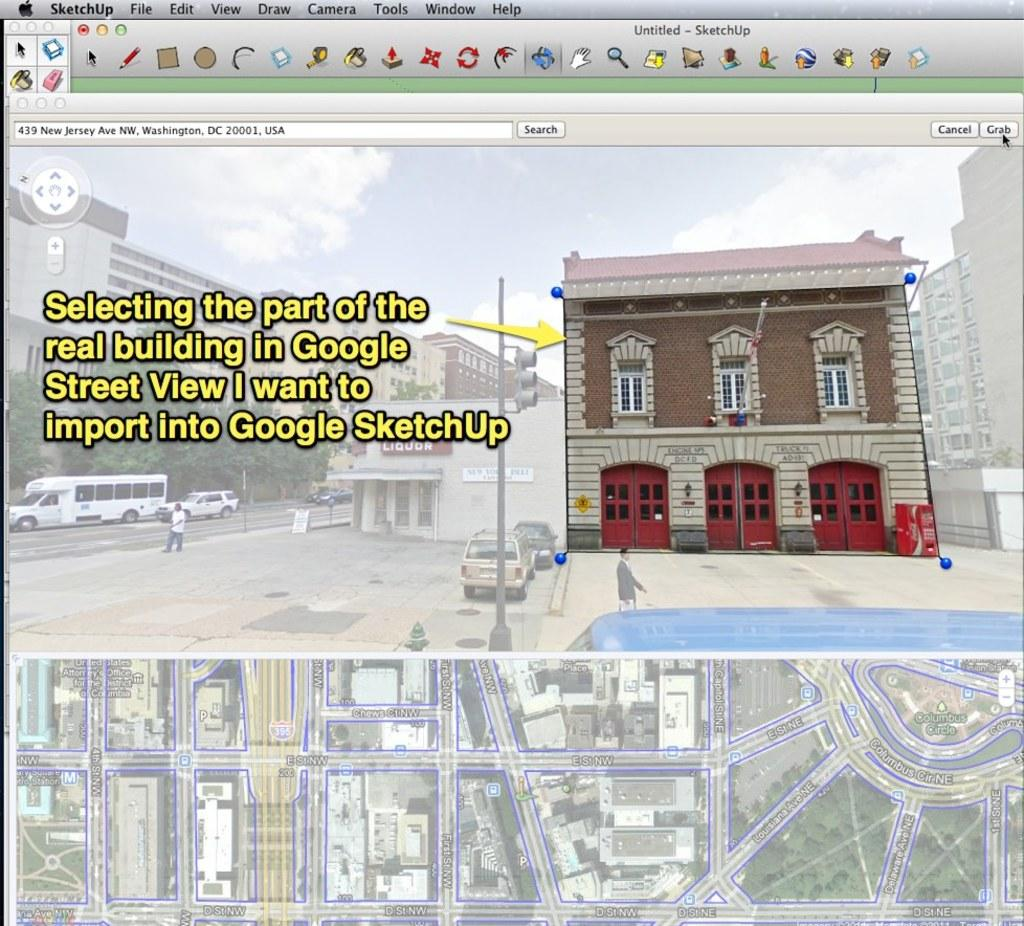What type of image is being displayed? The image is a screenshot. What can be seen on the right side of the image? There is a building on the right side of the image. What is present on the left side of the image? There is text on the left side of the image. What perspective is shown at the bottom of the image? There is an aerial view at the bottom of the image. How many beans are visible in the image? There are no beans present in the image. What type of vest is being worn by the person in the image? There is no person visible in the image, so it is not possible to determine if someone is wearing a vest. 